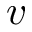Convert formula to latex. <formula><loc_0><loc_0><loc_500><loc_500>v</formula> 